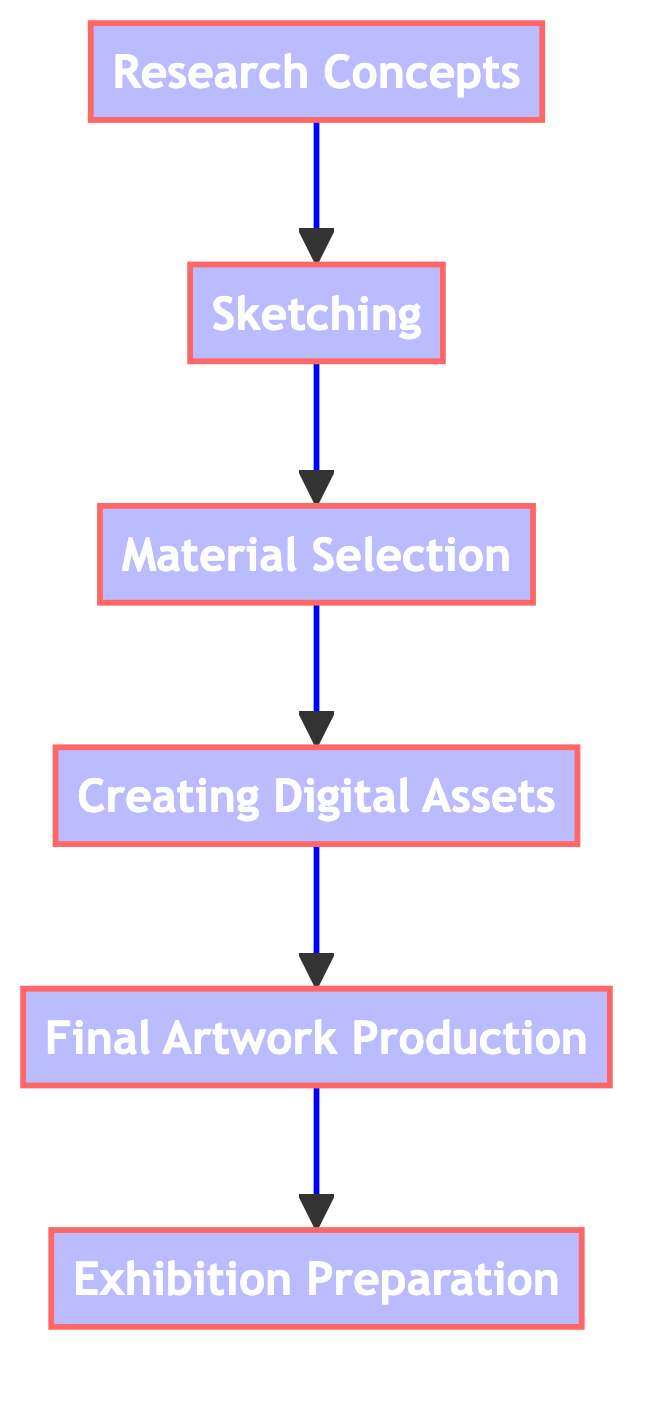What is the first stage of artwork creation? The first stage in the diagram is indicated by the node labeled "Research Concepts." It is the starting point from which all other stages flow.
Answer: Research Concepts How many nodes are present in the diagram? By counting, there are six distinct stages represented as nodes within the directed graph, including "Research Concepts," "Sketching," "Material Selection," "Creating Digital Assets," "Final Artwork Production," and "Exhibition Preparation."
Answer: 6 Which phase comes after "Material Selection"? The directed graph shows an edge pointing from "Material Selection" to "Creating Digital Assets," indicating that "Creating Digital Assets" follows "Material Selection."
Answer: Creating Digital Assets What is the last stage before "Exhibition Preparation"? Tracing the flow from the previous nodes, "Final Artwork Production" directly connects to "Exhibition Preparation," making it the penultimate stage.
Answer: Final Artwork Production How many edges are there in the diagram? The edges represent the connections between nodes, and by counting, there are five edges that define the flow from one stage of creation to the next throughout the diagram.
Answer: 5 What is the relationship between "Sketching" and "Material Selection"? The relationship is directional, as indicated by the edge that connects "Sketching" to "Material Selection," showing that "Sketching" precedes "Material Selection."
Answer: Sketching → Material Selection Which node represents the final step in the creation process? The node labeled "Exhibition Preparation" indicates the final step in the artwork creation, where the artwork is prepared for display.
Answer: Exhibition Preparation What are the two nodes that have no nodes directed towards them? Since "Research Concepts" is the initial stage, and no nodes point toward it, it has no incoming edges, along with all other nodes being part of a single process flow without any diverging paths.
Answer: Research Concepts, Sketching 